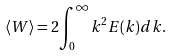<formula> <loc_0><loc_0><loc_500><loc_500>\langle W \rangle = 2 { \int _ { 0 } ^ { \infty } } k ^ { 2 } E ( k ) d k .</formula> 